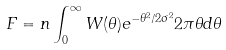<formula> <loc_0><loc_0><loc_500><loc_500>F = n \int _ { 0 } ^ { \infty } W ( \theta ) e ^ { - \theta ^ { 2 } / 2 \sigma ^ { 2 } } 2 \pi \theta d \theta</formula> 